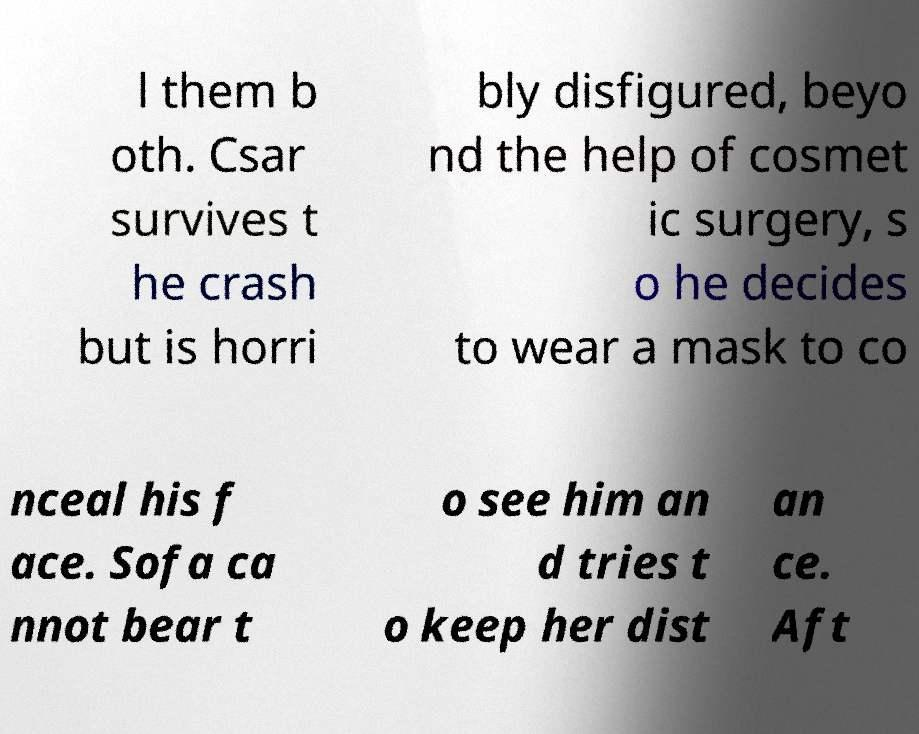Can you read and provide the text displayed in the image?This photo seems to have some interesting text. Can you extract and type it out for me? l them b oth. Csar survives t he crash but is horri bly disfigured, beyo nd the help of cosmet ic surgery, s o he decides to wear a mask to co nceal his f ace. Sofa ca nnot bear t o see him an d tries t o keep her dist an ce. Aft 